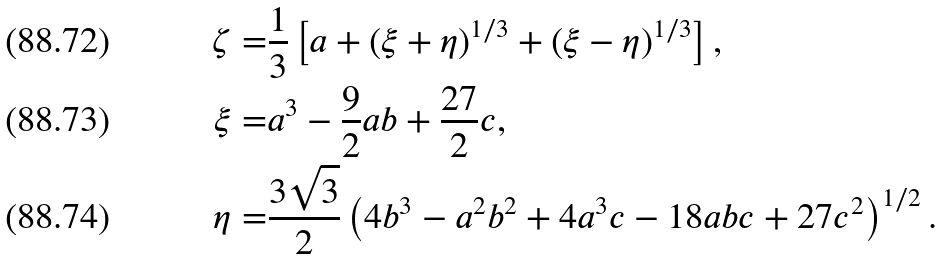Convert formula to latex. <formula><loc_0><loc_0><loc_500><loc_500>\zeta = & \frac { 1 } { 3 } \left [ a + ( \xi + \eta ) ^ { 1 / 3 } + ( \xi - \eta ) ^ { 1 / 3 } \right ] , \\ \xi = & a ^ { 3 } - \frac { 9 } { 2 } a b + \frac { 2 7 } { 2 } c , \\ \eta = & \frac { 3 \sqrt { 3 } } { 2 } \left ( 4 b ^ { 3 } - a ^ { 2 } b ^ { 2 } + 4 a ^ { 3 } c - 1 8 a b c + 2 7 c ^ { 2 } \right ) ^ { 1 / 2 } .</formula> 